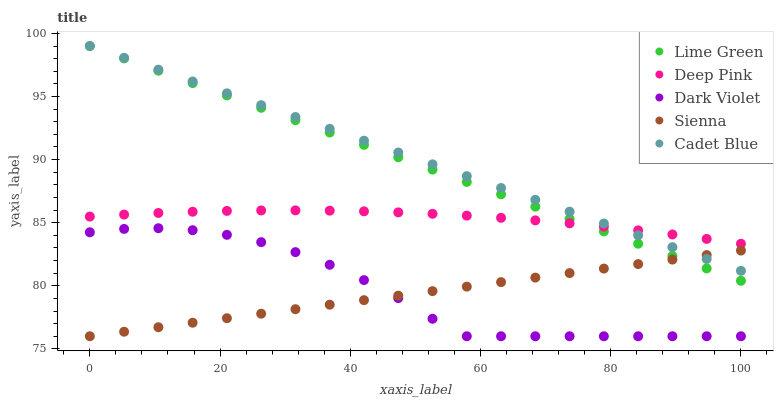Does Sienna have the minimum area under the curve?
Answer yes or no. Yes. Does Cadet Blue have the maximum area under the curve?
Answer yes or no. Yes. Does Deep Pink have the minimum area under the curve?
Answer yes or no. No. Does Deep Pink have the maximum area under the curve?
Answer yes or no. No. Is Lime Green the smoothest?
Answer yes or no. Yes. Is Dark Violet the roughest?
Answer yes or no. Yes. Is Cadet Blue the smoothest?
Answer yes or no. No. Is Cadet Blue the roughest?
Answer yes or no. No. Does Sienna have the lowest value?
Answer yes or no. Yes. Does Cadet Blue have the lowest value?
Answer yes or no. No. Does Lime Green have the highest value?
Answer yes or no. Yes. Does Deep Pink have the highest value?
Answer yes or no. No. Is Dark Violet less than Deep Pink?
Answer yes or no. Yes. Is Cadet Blue greater than Dark Violet?
Answer yes or no. Yes. Does Lime Green intersect Deep Pink?
Answer yes or no. Yes. Is Lime Green less than Deep Pink?
Answer yes or no. No. Is Lime Green greater than Deep Pink?
Answer yes or no. No. Does Dark Violet intersect Deep Pink?
Answer yes or no. No. 